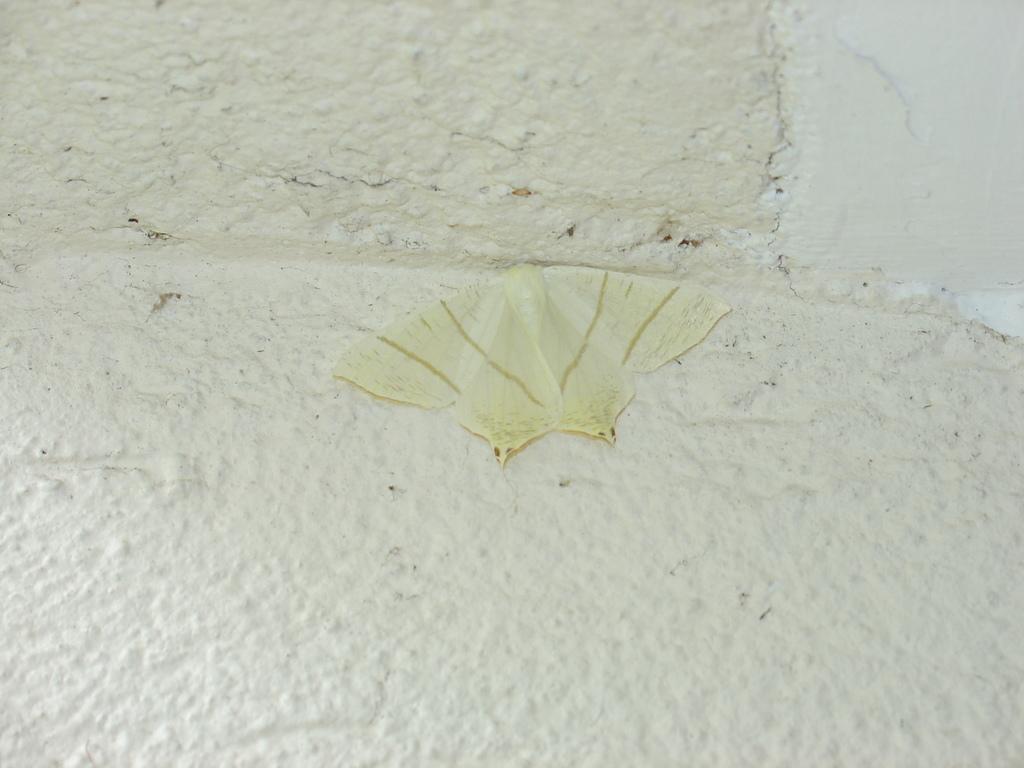Describe this image in one or two sentences. In this image I can see an insect is on the white surface. 